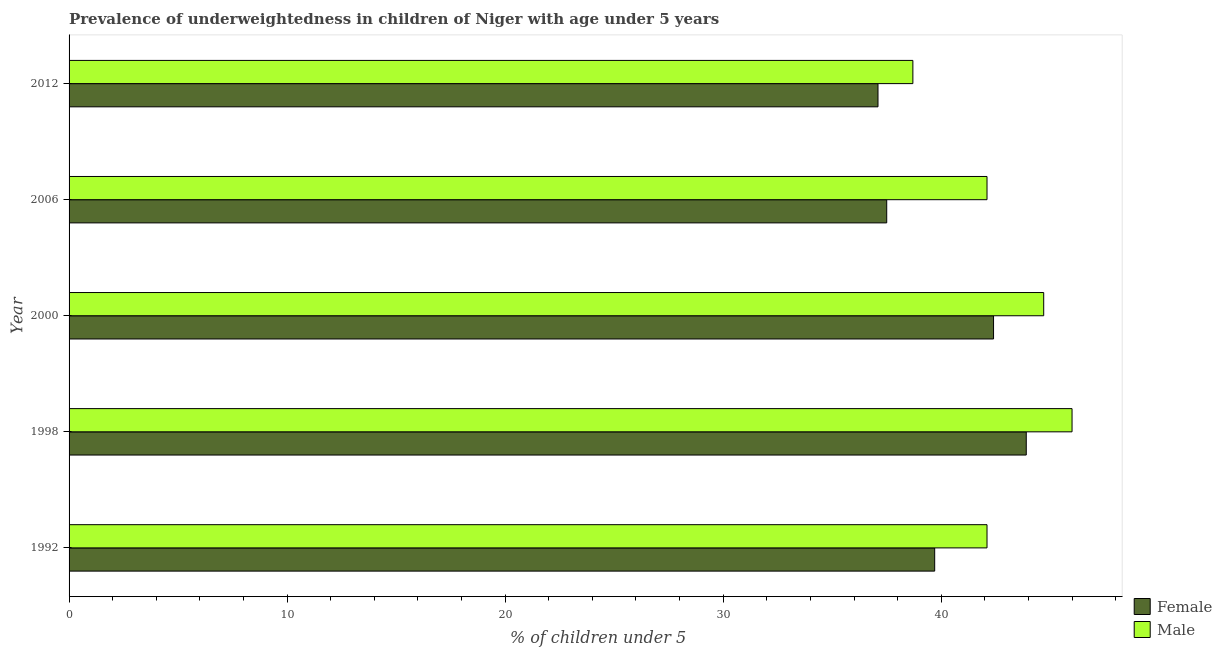How many bars are there on the 3rd tick from the top?
Ensure brevity in your answer.  2. What is the percentage of underweighted female children in 2006?
Provide a short and direct response. 37.5. Across all years, what is the maximum percentage of underweighted female children?
Ensure brevity in your answer.  43.9. Across all years, what is the minimum percentage of underweighted female children?
Provide a succinct answer. 37.1. What is the total percentage of underweighted female children in the graph?
Offer a terse response. 200.6. What is the difference between the percentage of underweighted female children in 1992 and that in 2000?
Offer a terse response. -2.7. What is the difference between the percentage of underweighted female children in 1998 and the percentage of underweighted male children in 1992?
Your response must be concise. 1.8. What is the average percentage of underweighted male children per year?
Offer a terse response. 42.72. What is the ratio of the percentage of underweighted male children in 2000 to that in 2006?
Your answer should be compact. 1.06. Is the difference between the percentage of underweighted female children in 1998 and 2000 greater than the difference between the percentage of underweighted male children in 1998 and 2000?
Give a very brief answer. Yes. In how many years, is the percentage of underweighted female children greater than the average percentage of underweighted female children taken over all years?
Offer a terse response. 2. Is the sum of the percentage of underweighted female children in 1998 and 2000 greater than the maximum percentage of underweighted male children across all years?
Keep it short and to the point. Yes. How many bars are there?
Offer a very short reply. 10. How many years are there in the graph?
Provide a succinct answer. 5. What is the difference between two consecutive major ticks on the X-axis?
Give a very brief answer. 10. Are the values on the major ticks of X-axis written in scientific E-notation?
Give a very brief answer. No. Does the graph contain any zero values?
Give a very brief answer. No. Does the graph contain grids?
Give a very brief answer. No. How are the legend labels stacked?
Offer a terse response. Vertical. What is the title of the graph?
Offer a very short reply. Prevalence of underweightedness in children of Niger with age under 5 years. Does "Electricity" appear as one of the legend labels in the graph?
Your response must be concise. No. What is the label or title of the X-axis?
Keep it short and to the point.  % of children under 5. What is the  % of children under 5 in Female in 1992?
Ensure brevity in your answer.  39.7. What is the  % of children under 5 in Male in 1992?
Your response must be concise. 42.1. What is the  % of children under 5 in Female in 1998?
Provide a short and direct response. 43.9. What is the  % of children under 5 of Male in 1998?
Your answer should be compact. 46. What is the  % of children under 5 in Female in 2000?
Your response must be concise. 42.4. What is the  % of children under 5 of Male in 2000?
Ensure brevity in your answer.  44.7. What is the  % of children under 5 in Female in 2006?
Your answer should be very brief. 37.5. What is the  % of children under 5 of Male in 2006?
Offer a terse response. 42.1. What is the  % of children under 5 of Female in 2012?
Provide a succinct answer. 37.1. What is the  % of children under 5 in Male in 2012?
Make the answer very short. 38.7. Across all years, what is the maximum  % of children under 5 in Female?
Your answer should be compact. 43.9. Across all years, what is the maximum  % of children under 5 in Male?
Make the answer very short. 46. Across all years, what is the minimum  % of children under 5 of Female?
Offer a very short reply. 37.1. Across all years, what is the minimum  % of children under 5 in Male?
Provide a short and direct response. 38.7. What is the total  % of children under 5 in Female in the graph?
Your response must be concise. 200.6. What is the total  % of children under 5 in Male in the graph?
Provide a short and direct response. 213.6. What is the difference between the  % of children under 5 of Female in 1992 and that in 1998?
Offer a terse response. -4.2. What is the difference between the  % of children under 5 of Female in 1992 and that in 2006?
Provide a succinct answer. 2.2. What is the difference between the  % of children under 5 in Female in 1992 and that in 2012?
Keep it short and to the point. 2.6. What is the difference between the  % of children under 5 of Male in 2000 and that in 2006?
Ensure brevity in your answer.  2.6. What is the difference between the  % of children under 5 in Male in 2000 and that in 2012?
Your answer should be compact. 6. What is the difference between the  % of children under 5 of Female in 2006 and that in 2012?
Keep it short and to the point. 0.4. What is the difference between the  % of children under 5 of Male in 2006 and that in 2012?
Your answer should be compact. 3.4. What is the difference between the  % of children under 5 in Female in 1992 and the  % of children under 5 in Male in 2000?
Give a very brief answer. -5. What is the difference between the  % of children under 5 of Female in 1998 and the  % of children under 5 of Male in 2006?
Your response must be concise. 1.8. What is the average  % of children under 5 in Female per year?
Give a very brief answer. 40.12. What is the average  % of children under 5 in Male per year?
Make the answer very short. 42.72. In the year 1992, what is the difference between the  % of children under 5 of Female and  % of children under 5 of Male?
Keep it short and to the point. -2.4. In the year 2000, what is the difference between the  % of children under 5 of Female and  % of children under 5 of Male?
Give a very brief answer. -2.3. What is the ratio of the  % of children under 5 of Female in 1992 to that in 1998?
Make the answer very short. 0.9. What is the ratio of the  % of children under 5 of Male in 1992 to that in 1998?
Make the answer very short. 0.92. What is the ratio of the  % of children under 5 of Female in 1992 to that in 2000?
Offer a terse response. 0.94. What is the ratio of the  % of children under 5 in Male in 1992 to that in 2000?
Keep it short and to the point. 0.94. What is the ratio of the  % of children under 5 of Female in 1992 to that in 2006?
Give a very brief answer. 1.06. What is the ratio of the  % of children under 5 of Male in 1992 to that in 2006?
Make the answer very short. 1. What is the ratio of the  % of children under 5 of Female in 1992 to that in 2012?
Your answer should be very brief. 1.07. What is the ratio of the  % of children under 5 in Male in 1992 to that in 2012?
Your response must be concise. 1.09. What is the ratio of the  % of children under 5 of Female in 1998 to that in 2000?
Your answer should be compact. 1.04. What is the ratio of the  % of children under 5 of Male in 1998 to that in 2000?
Your answer should be compact. 1.03. What is the ratio of the  % of children under 5 in Female in 1998 to that in 2006?
Your response must be concise. 1.17. What is the ratio of the  % of children under 5 in Male in 1998 to that in 2006?
Your answer should be very brief. 1.09. What is the ratio of the  % of children under 5 of Female in 1998 to that in 2012?
Provide a succinct answer. 1.18. What is the ratio of the  % of children under 5 in Male in 1998 to that in 2012?
Give a very brief answer. 1.19. What is the ratio of the  % of children under 5 of Female in 2000 to that in 2006?
Ensure brevity in your answer.  1.13. What is the ratio of the  % of children under 5 in Male in 2000 to that in 2006?
Your answer should be very brief. 1.06. What is the ratio of the  % of children under 5 in Female in 2000 to that in 2012?
Keep it short and to the point. 1.14. What is the ratio of the  % of children under 5 in Male in 2000 to that in 2012?
Your answer should be very brief. 1.16. What is the ratio of the  % of children under 5 in Female in 2006 to that in 2012?
Offer a very short reply. 1.01. What is the ratio of the  % of children under 5 in Male in 2006 to that in 2012?
Your response must be concise. 1.09. What is the difference between the highest and the second highest  % of children under 5 of Female?
Give a very brief answer. 1.5. What is the difference between the highest and the lowest  % of children under 5 in Female?
Offer a very short reply. 6.8. What is the difference between the highest and the lowest  % of children under 5 of Male?
Your answer should be compact. 7.3. 